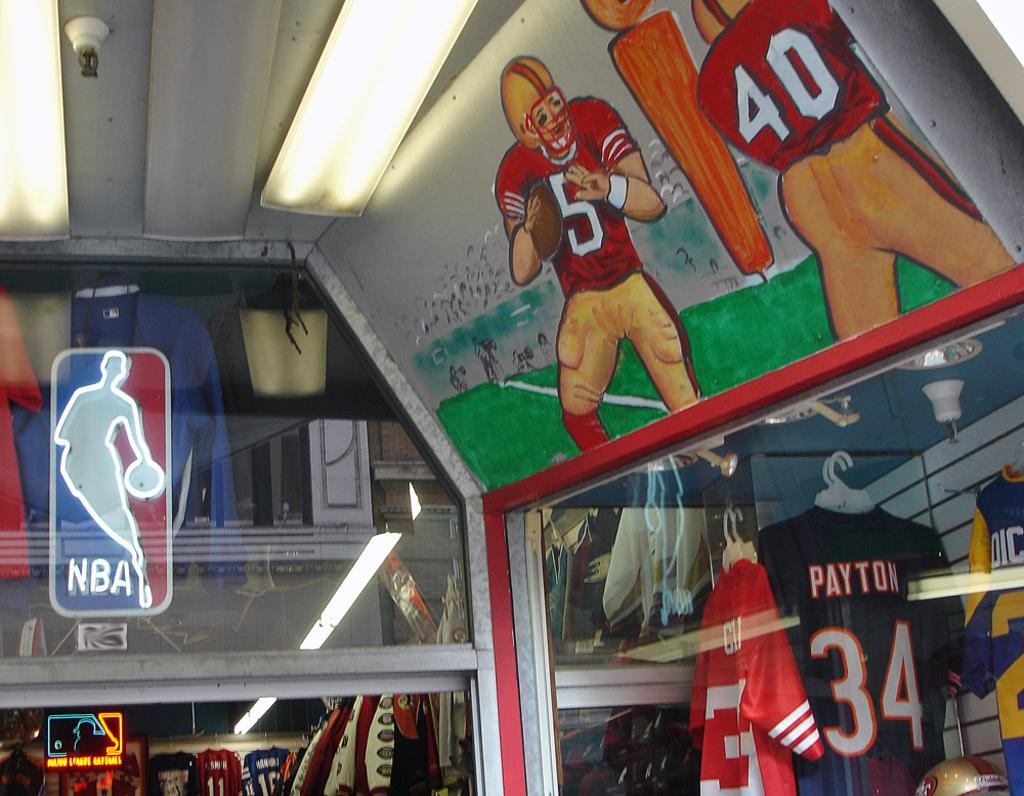<image>
Share a concise interpretation of the image provided. Walter Payton's number 34 jersey is one of many available at the store. 